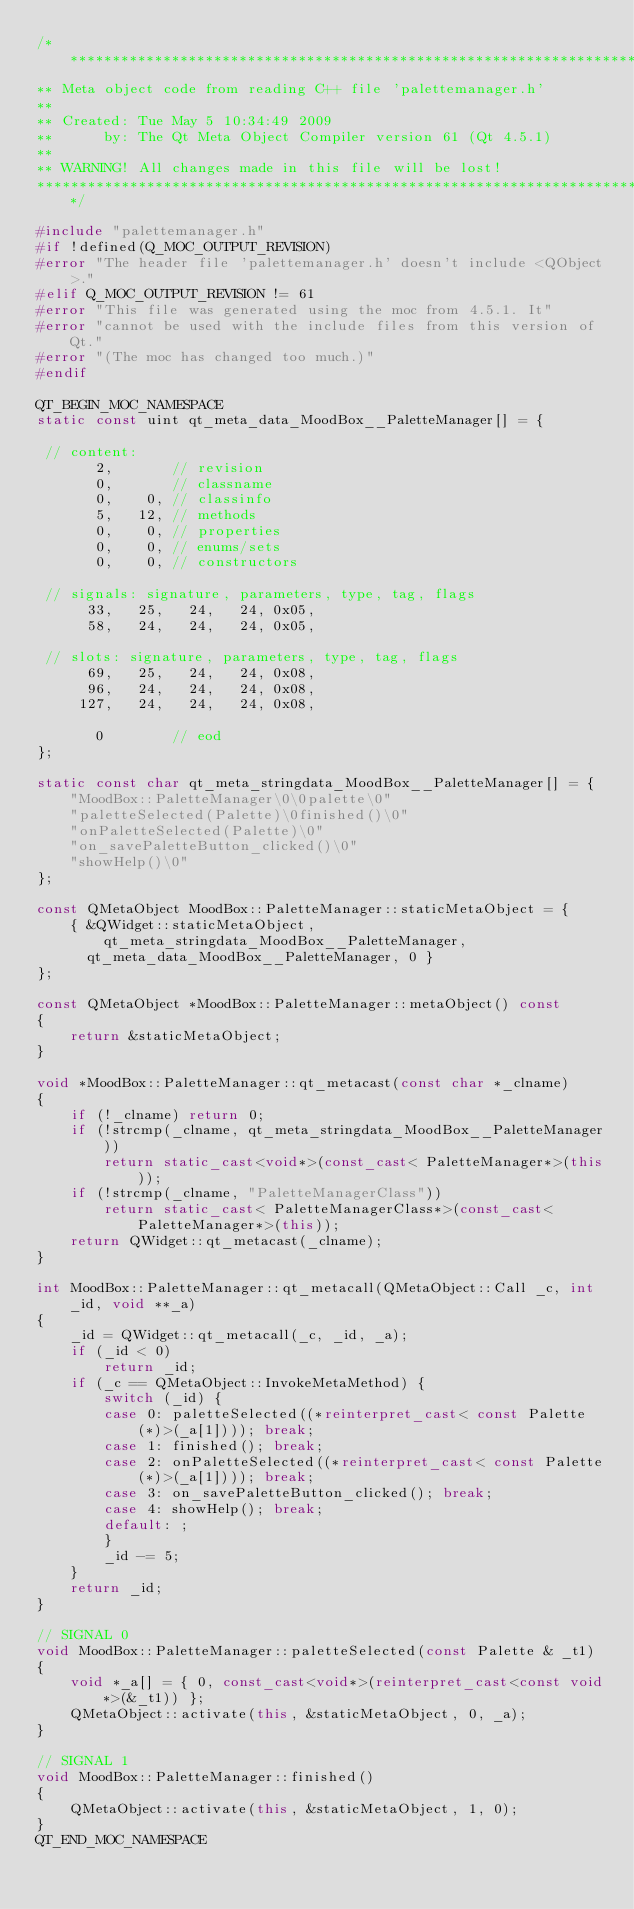<code> <loc_0><loc_0><loc_500><loc_500><_C++_>/****************************************************************************
** Meta object code from reading C++ file 'palettemanager.h'
**
** Created: Tue May 5 10:34:49 2009
**      by: The Qt Meta Object Compiler version 61 (Qt 4.5.1)
**
** WARNING! All changes made in this file will be lost!
*****************************************************************************/

#include "palettemanager.h"
#if !defined(Q_MOC_OUTPUT_REVISION)
#error "The header file 'palettemanager.h' doesn't include <QObject>."
#elif Q_MOC_OUTPUT_REVISION != 61
#error "This file was generated using the moc from 4.5.1. It"
#error "cannot be used with the include files from this version of Qt."
#error "(The moc has changed too much.)"
#endif

QT_BEGIN_MOC_NAMESPACE
static const uint qt_meta_data_MoodBox__PaletteManager[] = {

 // content:
       2,       // revision
       0,       // classname
       0,    0, // classinfo
       5,   12, // methods
       0,    0, // properties
       0,    0, // enums/sets
       0,    0, // constructors

 // signals: signature, parameters, type, tag, flags
      33,   25,   24,   24, 0x05,
      58,   24,   24,   24, 0x05,

 // slots: signature, parameters, type, tag, flags
      69,   25,   24,   24, 0x08,
      96,   24,   24,   24, 0x08,
     127,   24,   24,   24, 0x08,

       0        // eod
};

static const char qt_meta_stringdata_MoodBox__PaletteManager[] = {
    "MoodBox::PaletteManager\0\0palette\0"
    "paletteSelected(Palette)\0finished()\0"
    "onPaletteSelected(Palette)\0"
    "on_savePaletteButton_clicked()\0"
    "showHelp()\0"
};

const QMetaObject MoodBox::PaletteManager::staticMetaObject = {
    { &QWidget::staticMetaObject, qt_meta_stringdata_MoodBox__PaletteManager,
      qt_meta_data_MoodBox__PaletteManager, 0 }
};

const QMetaObject *MoodBox::PaletteManager::metaObject() const
{
    return &staticMetaObject;
}

void *MoodBox::PaletteManager::qt_metacast(const char *_clname)
{
    if (!_clname) return 0;
    if (!strcmp(_clname, qt_meta_stringdata_MoodBox__PaletteManager))
        return static_cast<void*>(const_cast< PaletteManager*>(this));
    if (!strcmp(_clname, "PaletteManagerClass"))
        return static_cast< PaletteManagerClass*>(const_cast< PaletteManager*>(this));
    return QWidget::qt_metacast(_clname);
}

int MoodBox::PaletteManager::qt_metacall(QMetaObject::Call _c, int _id, void **_a)
{
    _id = QWidget::qt_metacall(_c, _id, _a);
    if (_id < 0)
        return _id;
    if (_c == QMetaObject::InvokeMetaMethod) {
        switch (_id) {
        case 0: paletteSelected((*reinterpret_cast< const Palette(*)>(_a[1]))); break;
        case 1: finished(); break;
        case 2: onPaletteSelected((*reinterpret_cast< const Palette(*)>(_a[1]))); break;
        case 3: on_savePaletteButton_clicked(); break;
        case 4: showHelp(); break;
        default: ;
        }
        _id -= 5;
    }
    return _id;
}

// SIGNAL 0
void MoodBox::PaletteManager::paletteSelected(const Palette & _t1)
{
    void *_a[] = { 0, const_cast<void*>(reinterpret_cast<const void*>(&_t1)) };
    QMetaObject::activate(this, &staticMetaObject, 0, _a);
}

// SIGNAL 1
void MoodBox::PaletteManager::finished()
{
    QMetaObject::activate(this, &staticMetaObject, 1, 0);
}
QT_END_MOC_NAMESPACE
</code> 